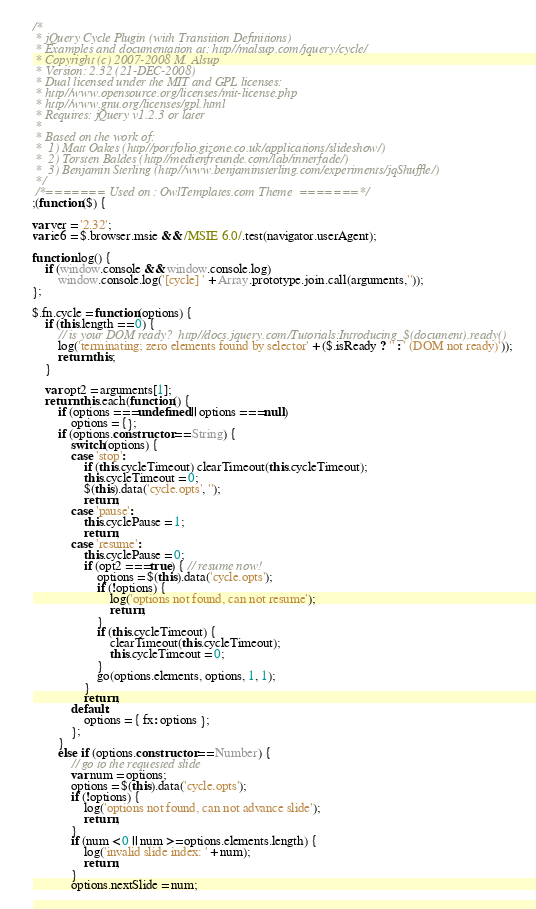Convert code to text. <code><loc_0><loc_0><loc_500><loc_500><_JavaScript_>/*
 * jQuery Cycle Plugin (with Transition Definitions)
 * Examples and documentation at: http//malsup.com/jquery/cycle/
 * Copyright (c) 2007-2008 M. Alsup
 * Version: 2.32 (21-DEC-2008)
 * Dual licensed under the MIT and GPL licenses:
 * http//www.opensource.org/licenses/mit-license.php
 * http//www.gnu.org/licenses/gpl.html
 * Requires: jQuery v1.2.3 or later
 *
 * Based on the work of:
 *	1) Matt Oakes (http//portfolio.gizone.co.uk/applications/slideshow/)
 *	2) Torsten Baldes (http//medienfreunde.com/lab/innerfade/)
 *	3) Benjamin Sterling (http//www.benjaminsterling.com/experiments/jqShuffle/)
 */
 /*======= Used on : OwlTemplates.com Theme  =======*/
;(function($) {

var ver = '2.32';
var ie6 = $.browser.msie && /MSIE 6.0/.test(navigator.userAgent);

function log() {
	if (window.console && window.console.log)
		window.console.log('[cycle] ' + Array.prototype.join.call(arguments,''));
};

$.fn.cycle = function(options) {
	if (this.length == 0) {
		// is your DOM ready?  http//docs.jquery.com/Tutorials:Introducing_$(document).ready()
		log('terminating; zero elements found by selector' + ($.isReady ? '' : ' (DOM not ready)'));
		return this;
	}

	var opt2 = arguments[1];
	return this.each(function() {
		if (options === undefined || options === null)
			options = {};
		if (options.constructor == String) {
			switch(options) {
			case 'stop':
				if (this.cycleTimeout) clearTimeout(this.cycleTimeout);
				this.cycleTimeout = 0;
				$(this).data('cycle.opts', '');
				return;
			case 'pause':
				this.cyclePause = 1;
				return;
			case 'resume':
				this.cyclePause = 0;
				if (opt2 === true) { // resume now!
					options = $(this).data('cycle.opts');
					if (!options) {
						log('options not found, can not resume');
						return;
					}
					if (this.cycleTimeout) {
						clearTimeout(this.cycleTimeout);
						this.cycleTimeout = 0;
					}			 
					go(options.elements, options, 1, 1);
				}
				return;
			default:
				options = { fx: options };
			};
		}
		else if (options.constructor == Number) {
			// go to the requested slide
			var num = options;
			options = $(this).data('cycle.opts');
			if (!options) {
				log('options not found, can not advance slide');
				return;
			}
			if (num < 0 || num >= options.elements.length) {
				log('invalid slide index: ' + num);
				return;
			}
			options.nextSlide = num;</code> 